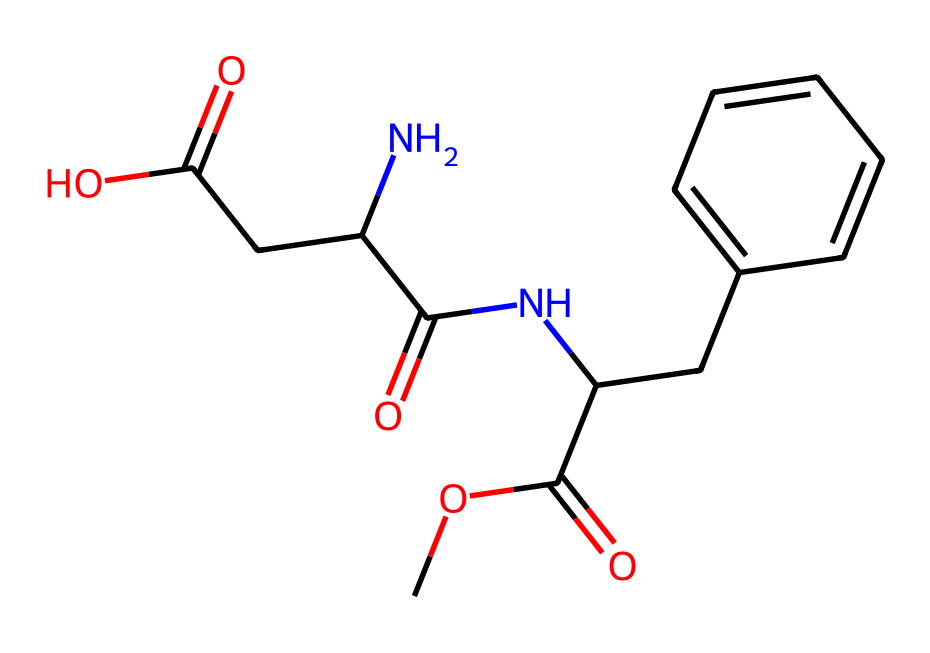What is the main functional group present in aspartame? The main functional group in aspartame is the amide group, which is characterized by the presence of a nitrogen atom bonded to a carbonyl (C=O) group. In the SMILES provided, the presence of 'NC(=O)' indicates the presence of this amide functional group.
Answer: amide group How many carbon atoms are present in the structure of aspartame? By analyzing the SMILES representation, we can count the number of carbon atoms. The structure includes multiple carbon atoms in both the aromatic ring and the aliphatic chain. Counting these gives a total of 13 carbon atoms.
Answer: 13 What type of chemical is aspartame classified as? Aspartame is classified as a dipeptide, which is evident from the presence of two amino acids in its structure (as indicated by the nitrogen and carbonyl groups). The overall structure indicates that it is derived from the combination of two amino acids, making it a peptide.
Answer: dipeptide Which components in the structure of aspartame contribute to its sweetness? The sweetness of aspartame is primarily attributed to the specific arrangement of its functional groups, particularly the ester and amide groups, which interact with the sweetness receptors on the tongue. The presence of both functional groups creates the sweet flavor characteristic of aspartame.
Answer: ester and amide groups What is the molecular weight of aspartame approximately? To estimate the molecular weight of aspartame, we sum the atomic weights of each atom present, using the SMILES representation. This calculation provides an approximate molecular weight of around 294.3 g/mol for aspartame.
Answer: 294.3 g/mol 